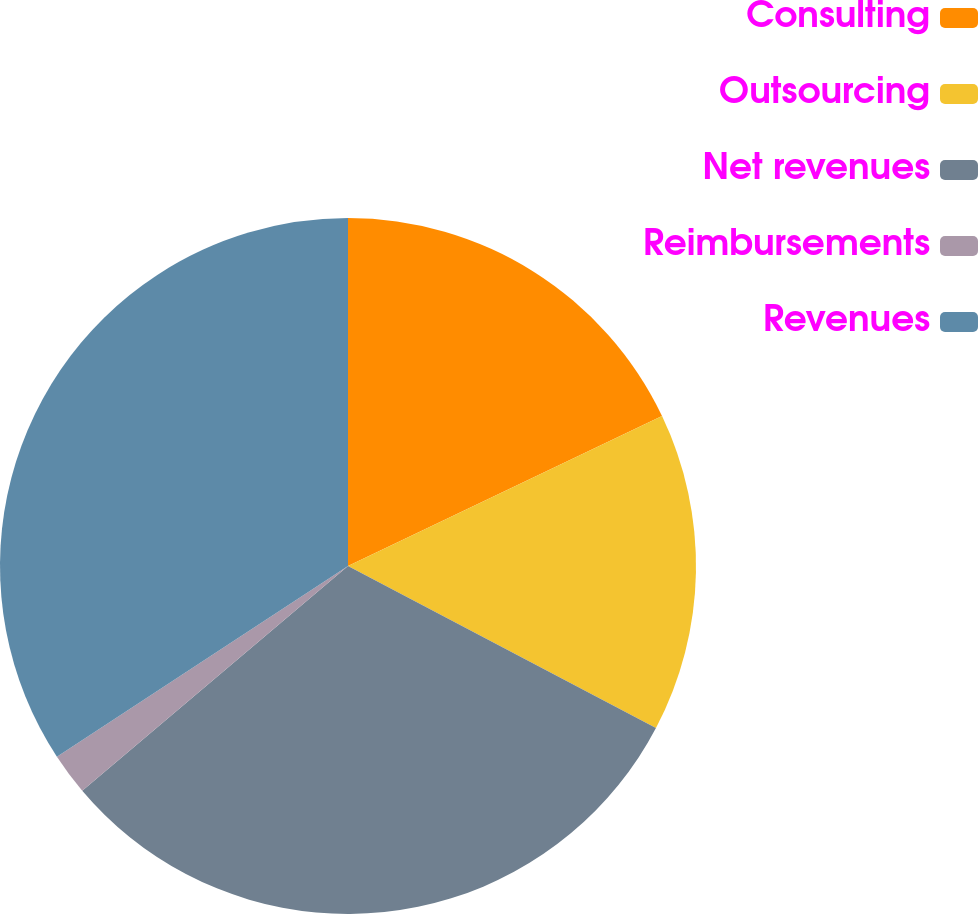Convert chart. <chart><loc_0><loc_0><loc_500><loc_500><pie_chart><fcel>Consulting<fcel>Outsourcing<fcel>Net revenues<fcel>Reimbursements<fcel>Revenues<nl><fcel>17.91%<fcel>14.8%<fcel>31.12%<fcel>1.94%<fcel>34.23%<nl></chart> 